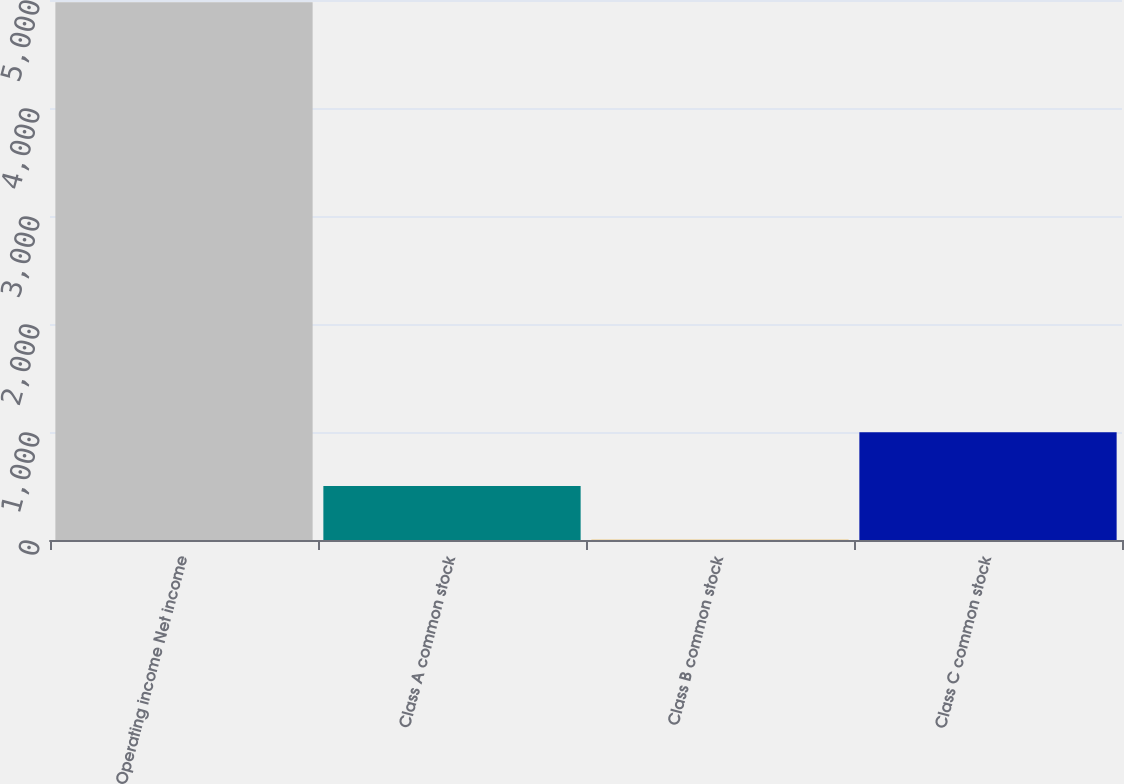Convert chart to OTSL. <chart><loc_0><loc_0><loc_500><loc_500><bar_chart><fcel>Operating income Net income<fcel>Class A common stock<fcel>Class B common stock<fcel>Class C common stock<nl><fcel>4980<fcel>500.88<fcel>3.2<fcel>998.56<nl></chart> 